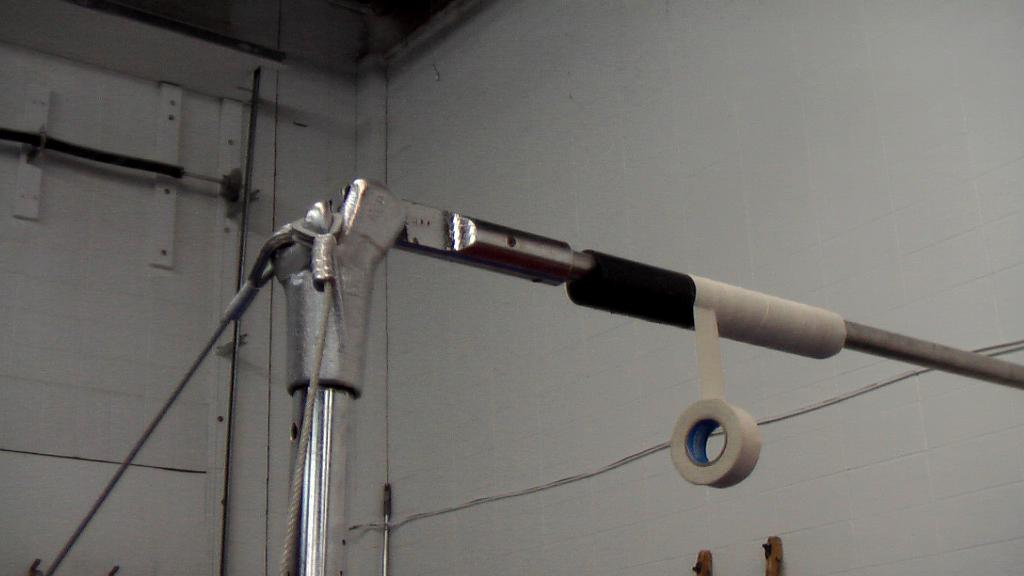What is present on the stand in the image? There is a rope and a tape on the stand in the image. What else can be seen in the image besides the rope and tape? There are objects visible in the image. What is visible in the background of the image? A wall is visible in the background of the image. Is there a baseball game happening in the image? There is no indication of a baseball game or any baseball-related objects in the image. 